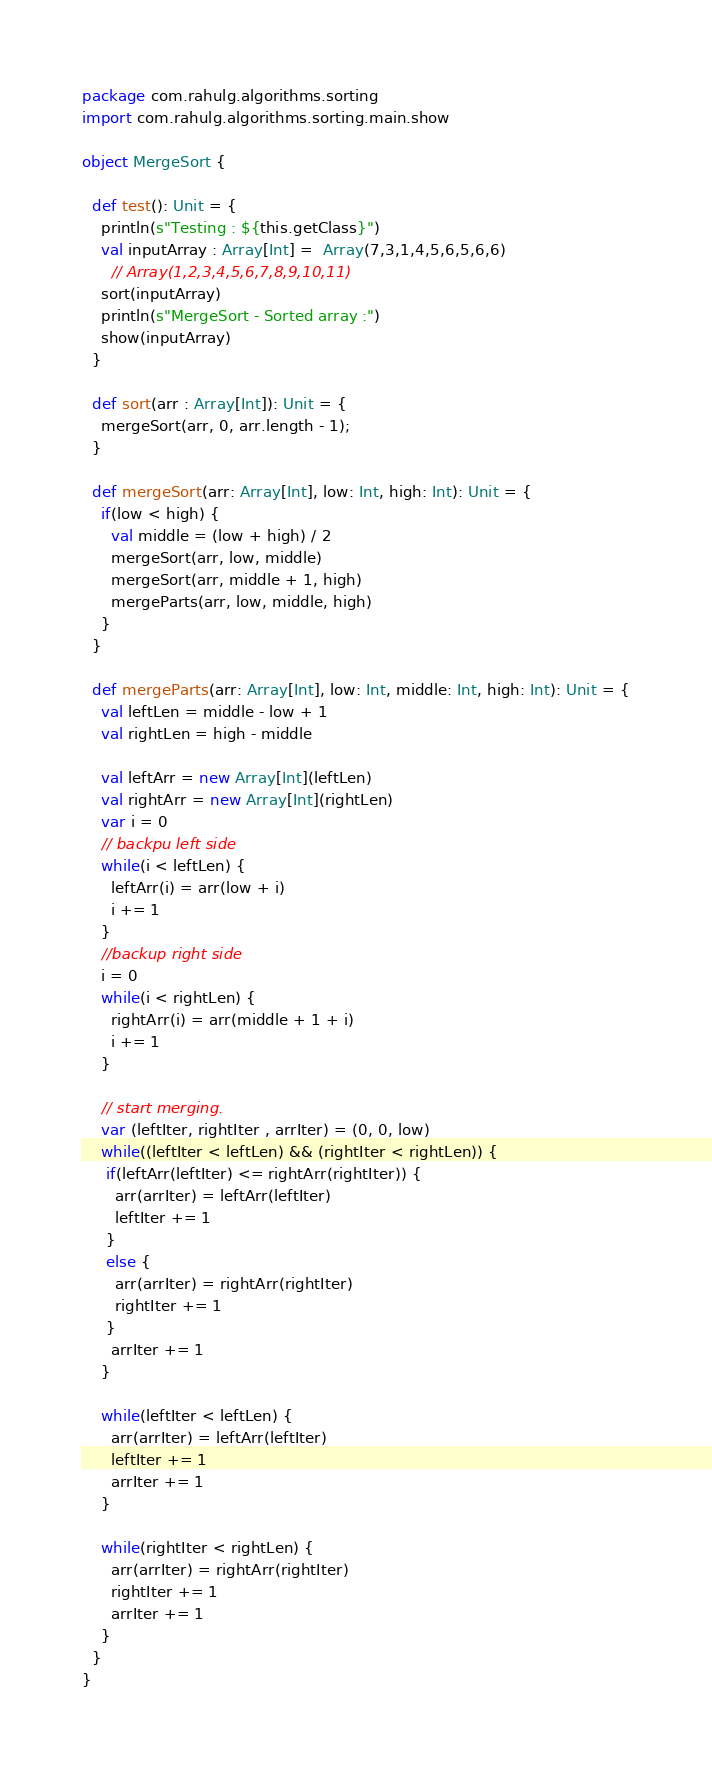<code> <loc_0><loc_0><loc_500><loc_500><_Scala_>package com.rahulg.algorithms.sorting
import com.rahulg.algorithms.sorting.main.show

object MergeSort {

  def test(): Unit = {
    println(s"Testing : ${this.getClass}")
    val inputArray : Array[Int] =  Array(7,3,1,4,5,6,5,6,6)
      // Array(1,2,3,4,5,6,7,8,9,10,11)
    sort(inputArray)
    println(s"MergeSort - Sorted array :")
    show(inputArray)
  }

  def sort(arr : Array[Int]): Unit = {
    mergeSort(arr, 0, arr.length - 1);
  }

  def mergeSort(arr: Array[Int], low: Int, high: Int): Unit = {
    if(low < high) {
      val middle = (low + high) / 2
      mergeSort(arr, low, middle)
      mergeSort(arr, middle + 1, high)
      mergeParts(arr, low, middle, high)
    }
  }

  def mergeParts(arr: Array[Int], low: Int, middle: Int, high: Int): Unit = {
    val leftLen = middle - low + 1
    val rightLen = high - middle

    val leftArr = new Array[Int](leftLen)
    val rightArr = new Array[Int](rightLen)
    var i = 0
    // backpu left side
    while(i < leftLen) {
      leftArr(i) = arr(low + i)
      i += 1
    }
    //backup right side
    i = 0
    while(i < rightLen) {
      rightArr(i) = arr(middle + 1 + i)
      i += 1
    }

    // start merging.
    var (leftIter, rightIter , arrIter) = (0, 0, low)
    while((leftIter < leftLen) && (rightIter < rightLen)) {
     if(leftArr(leftIter) <= rightArr(rightIter)) {
       arr(arrIter) = leftArr(leftIter)
       leftIter += 1
     }
     else {
       arr(arrIter) = rightArr(rightIter)
       rightIter += 1
     }
      arrIter += 1
    }

    while(leftIter < leftLen) {
      arr(arrIter) = leftArr(leftIter)
      leftIter += 1
      arrIter += 1
    }

    while(rightIter < rightLen) {
      arr(arrIter) = rightArr(rightIter)
      rightIter += 1
      arrIter += 1
    }
  }
}
</code> 